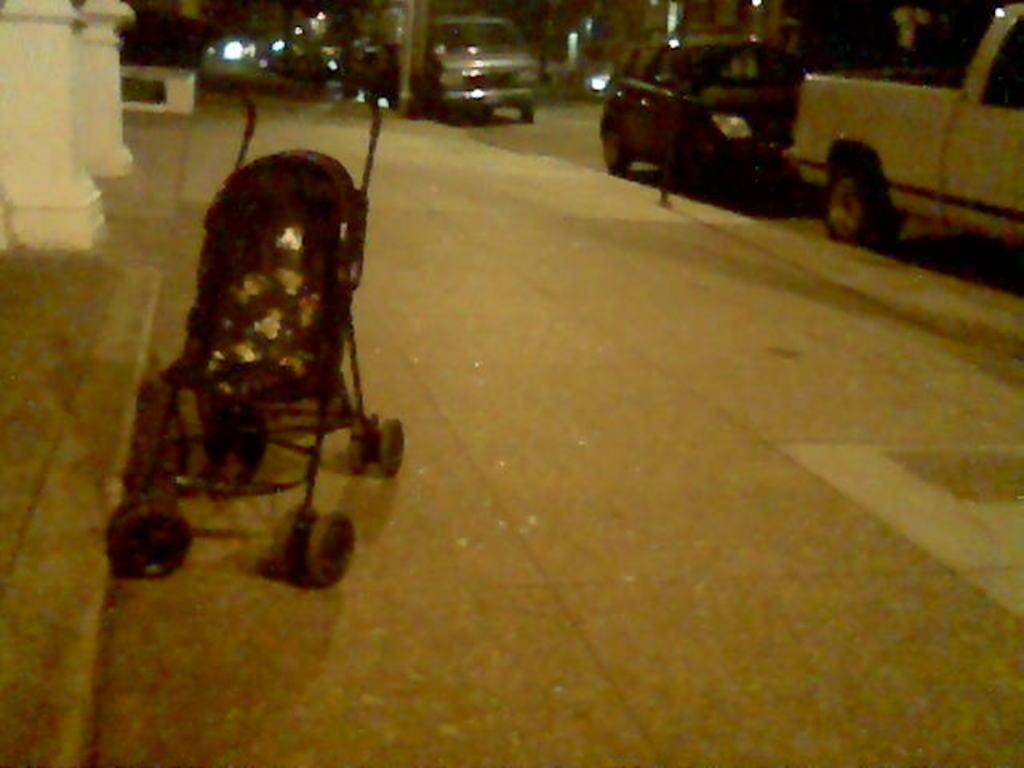In one or two sentences, can you explain what this image depicts? In the image there is a baby stroller on the footpath and behind that there are two pillars, on the right side there are few vehicles on the road. 